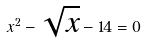<formula> <loc_0><loc_0><loc_500><loc_500>x ^ { 2 } - \sqrt { x } - 1 4 = 0</formula> 